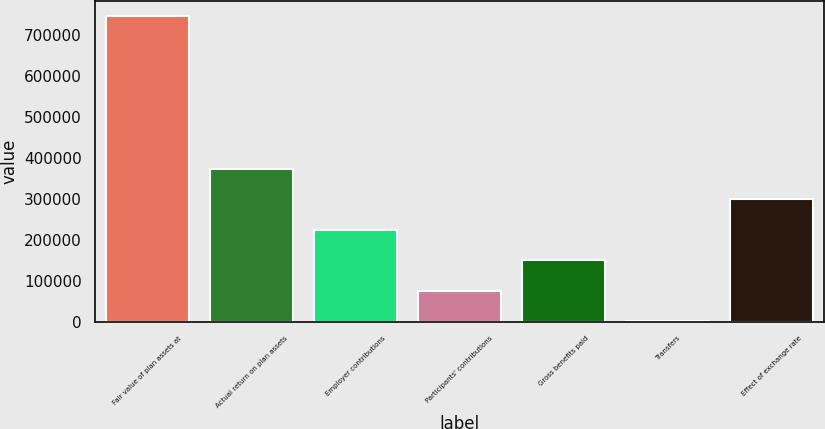Convert chart to OTSL. <chart><loc_0><loc_0><loc_500><loc_500><bar_chart><fcel>Fair value of plan assets at<fcel>Actual return on plan assets<fcel>Employer contributions<fcel>Participants' contributions<fcel>Gross benefits paid<fcel>Transfers<fcel>Effect of exchange rate<nl><fcel>746189<fcel>374028<fcel>225164<fcel>76300.1<fcel>150732<fcel>1868<fcel>299596<nl></chart> 